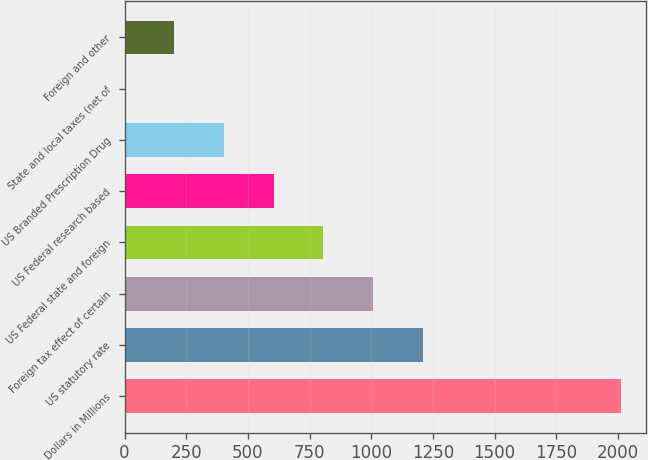Convert chart to OTSL. <chart><loc_0><loc_0><loc_500><loc_500><bar_chart><fcel>Dollars in Millions<fcel>US statutory rate<fcel>Foreign tax effect of certain<fcel>US Federal state and foreign<fcel>US Federal research based<fcel>US Branded Prescription Drug<fcel>State and local taxes (net of<fcel>Foreign and other<nl><fcel>2014<fcel>1208.72<fcel>1007.4<fcel>806.08<fcel>604.76<fcel>403.44<fcel>0.8<fcel>202.12<nl></chart> 